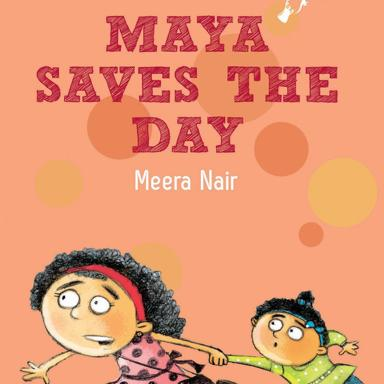Can you explain the significance of the color choices and design elements used on the book cover? The book cover employs a bold orange backdrop that evokes feelings of enthusiasm and playfulness, suitable for a children's adventure tale. The use of circles in varying sizes contributes to the sense of movement and excitement. The characters' contrasting outfits in pink, black, green, and yellow further draw the eye and highlight their personalities. Such visual strategies are commonly used to captivate a young audience and suggest a narrative full of fun, learning, and growth. 